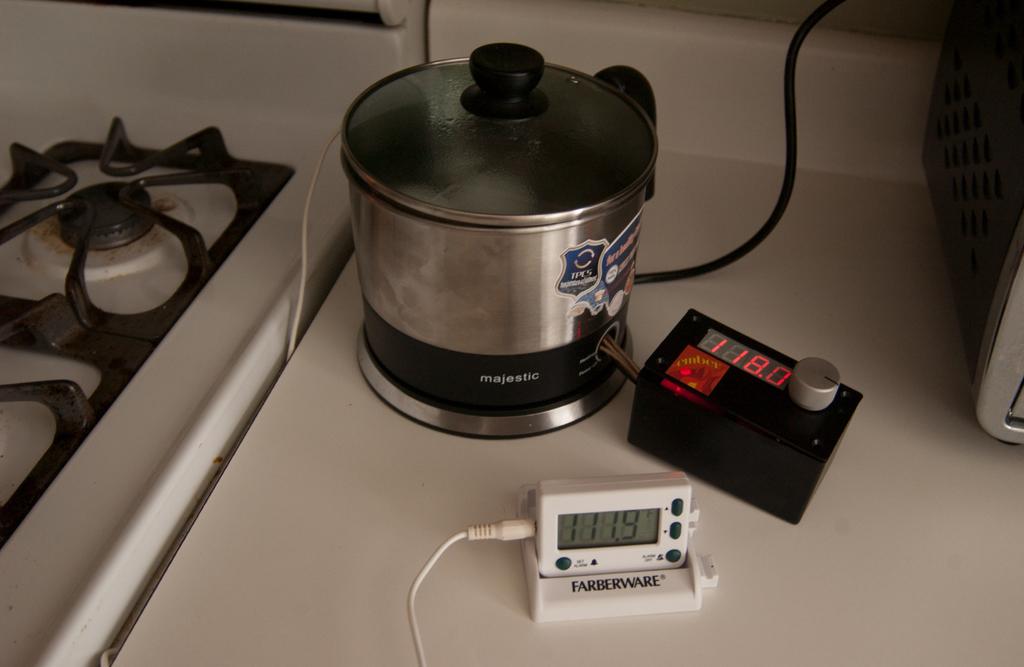What time does the white device read?
Give a very brief answer. 11:19. What numbers are on the white device?
Offer a terse response. 111.9. 